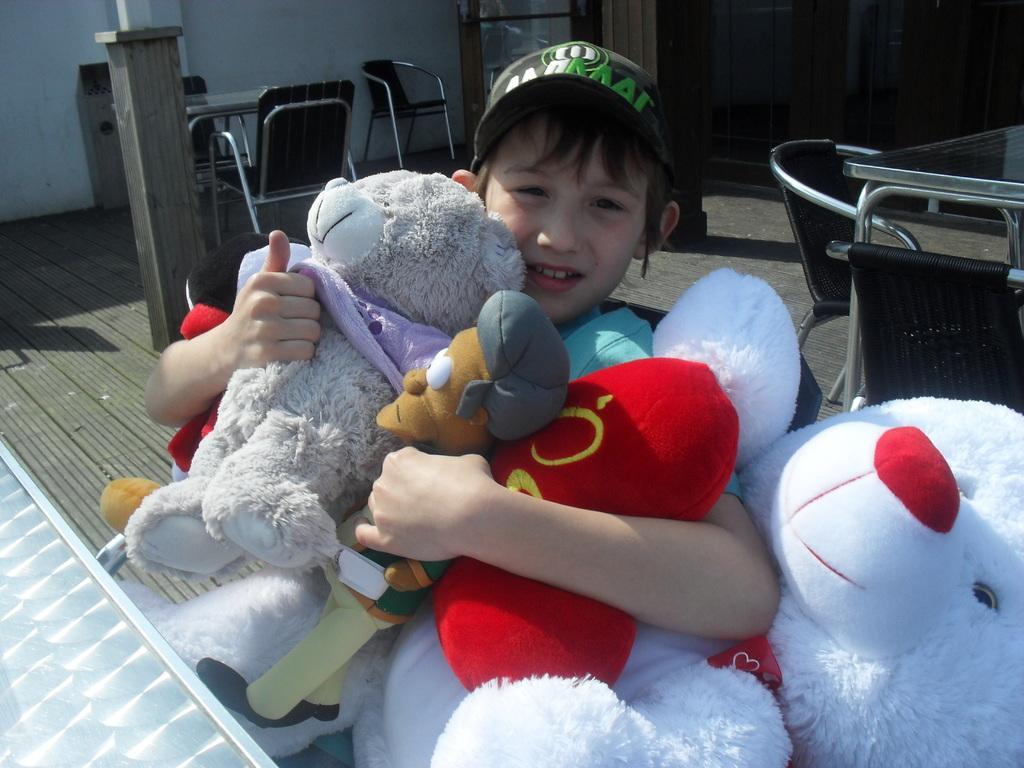How would you summarize this image in a sentence or two? In this picture we can see a boy wore a cap, holding toys with his hands and in the background we can see chairs, tables on the floor, wall, some objects. 